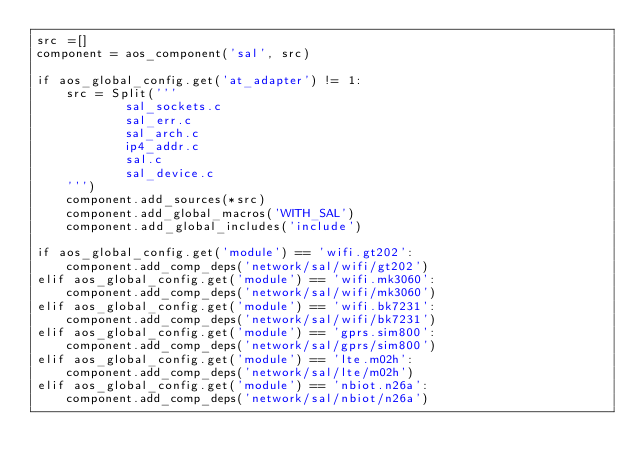Convert code to text. <code><loc_0><loc_0><loc_500><loc_500><_Python_>src =[]
component = aos_component('sal', src)

if aos_global_config.get('at_adapter') != 1:
    src = Split('''
            sal_sockets.c 
            sal_err.c 
            sal_arch.c 
            ip4_addr.c 
            sal.c
            sal_device.c
    ''')
    component.add_sources(*src)
    component.add_global_macros('WITH_SAL')
    component.add_global_includes('include')

if aos_global_config.get('module') == 'wifi.gt202':
    component.add_comp_deps('network/sal/wifi/gt202')
elif aos_global_config.get('module') == 'wifi.mk3060':
    component.add_comp_deps('network/sal/wifi/mk3060')
elif aos_global_config.get('module') == 'wifi.bk7231':
    component.add_comp_deps('network/sal/wifi/bk7231')
elif aos_global_config.get('module') == 'gprs.sim800':
    component.add_comp_deps('network/sal/gprs/sim800')
elif aos_global_config.get('module') == 'lte.m02h':
    component.add_comp_deps('network/sal/lte/m02h')
elif aos_global_config.get('module') == 'nbiot.n26a':
    component.add_comp_deps('network/sal/nbiot/n26a')
</code> 